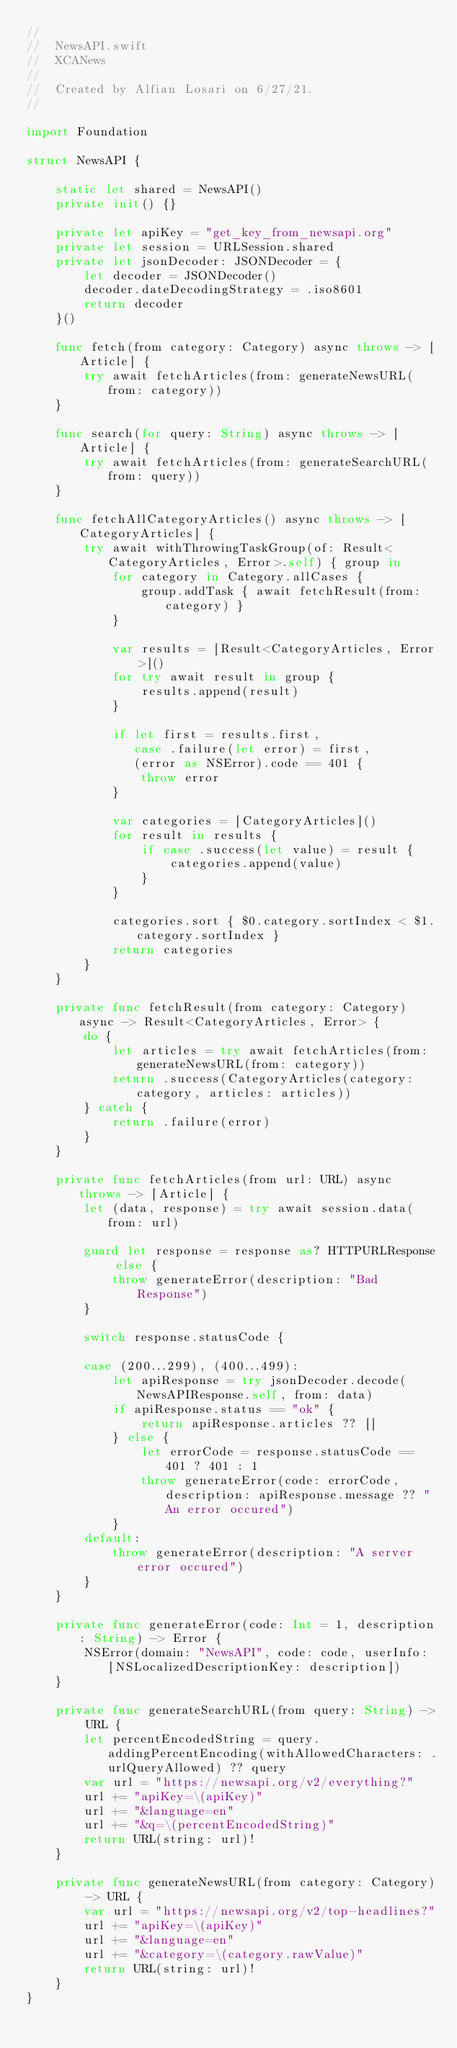Convert code to text. <code><loc_0><loc_0><loc_500><loc_500><_Swift_>//
//  NewsAPI.swift
//  XCANews
//
//  Created by Alfian Losari on 6/27/21.
//

import Foundation

struct NewsAPI {
    
    static let shared = NewsAPI()
    private init() {}
    
    private let apiKey = "get_key_from_newsapi.org"
    private let session = URLSession.shared
    private let jsonDecoder: JSONDecoder = {
        let decoder = JSONDecoder()
        decoder.dateDecodingStrategy = .iso8601
        return decoder
    }()
    
    func fetch(from category: Category) async throws -> [Article] {
        try await fetchArticles(from: generateNewsURL(from: category))
    }
    
    func search(for query: String) async throws -> [Article] {
        try await fetchArticles(from: generateSearchURL(from: query))
    }
    
    func fetchAllCategoryArticles() async throws -> [CategoryArticles] {
        try await withThrowingTaskGroup(of: Result<CategoryArticles, Error>.self) { group in
            for category in Category.allCases {
                group.addTask { await fetchResult(from: category) }
            }
            
            var results = [Result<CategoryArticles, Error>]()
            for try await result in group {
                results.append(result)
            }
            
            if let first = results.first,
               case .failure(let error) = first,
               (error as NSError).code == 401 {
                throw error
            }
            
            var categories = [CategoryArticles]()
            for result in results {
                if case .success(let value) = result {
                    categories.append(value)
                }
            }
            
            categories.sort { $0.category.sortIndex < $1.category.sortIndex }
            return categories
        }
    }
    
    private func fetchResult(from category: Category) async -> Result<CategoryArticles, Error> {
        do {
            let articles = try await fetchArticles(from: generateNewsURL(from: category))
            return .success(CategoryArticles(category: category, articles: articles))
        } catch {
            return .failure(error)
        }
    }
    
    private func fetchArticles(from url: URL) async throws -> [Article] {
        let (data, response) = try await session.data(from: url)
        
        guard let response = response as? HTTPURLResponse else {
            throw generateError(description: "Bad Response")
        }
        
        switch response.statusCode {
            
        case (200...299), (400...499):
            let apiResponse = try jsonDecoder.decode(NewsAPIResponse.self, from: data)
            if apiResponse.status == "ok" {
                return apiResponse.articles ?? []
            } else {
                let errorCode = response.statusCode == 401 ? 401 : 1
                throw generateError(code: errorCode, description: apiResponse.message ?? "An error occured")
            }
        default:
            throw generateError(description: "A server error occured")
        }
    }
    
    private func generateError(code: Int = 1, description: String) -> Error {
        NSError(domain: "NewsAPI", code: code, userInfo: [NSLocalizedDescriptionKey: description])
    }
    
    private func generateSearchURL(from query: String) -> URL {
        let percentEncodedString = query.addingPercentEncoding(withAllowedCharacters: .urlQueryAllowed) ?? query
        var url = "https://newsapi.org/v2/everything?"
        url += "apiKey=\(apiKey)"
        url += "&language=en"
        url += "&q=\(percentEncodedString)"
        return URL(string: url)!
    }
    
    private func generateNewsURL(from category: Category) -> URL {
        var url = "https://newsapi.org/v2/top-headlines?"
        url += "apiKey=\(apiKey)"
        url += "&language=en"
        url += "&category=\(category.rawValue)"
        return URL(string: url)!
    }
}
</code> 